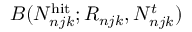<formula> <loc_0><loc_0><loc_500><loc_500>B ( N _ { n j k } ^ { h i t } ; R _ { n j k } , N _ { n j k } ^ { t } )</formula> 